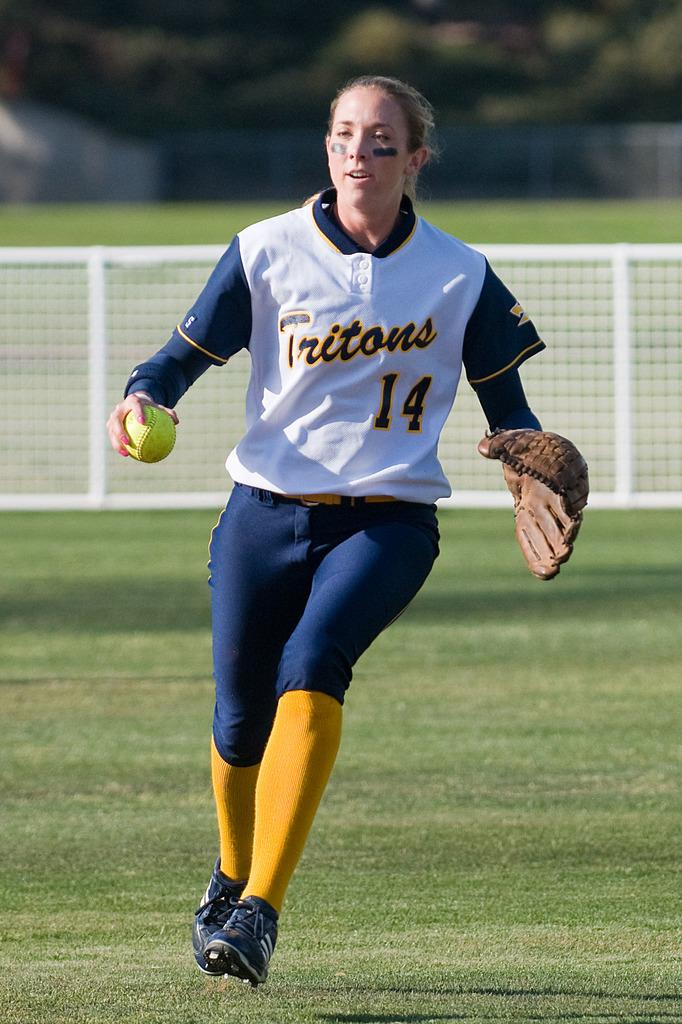<image>
Offer a succinct explanation of the picture presented. Baseball player wearing a jersey for the Tritons running on the field. 